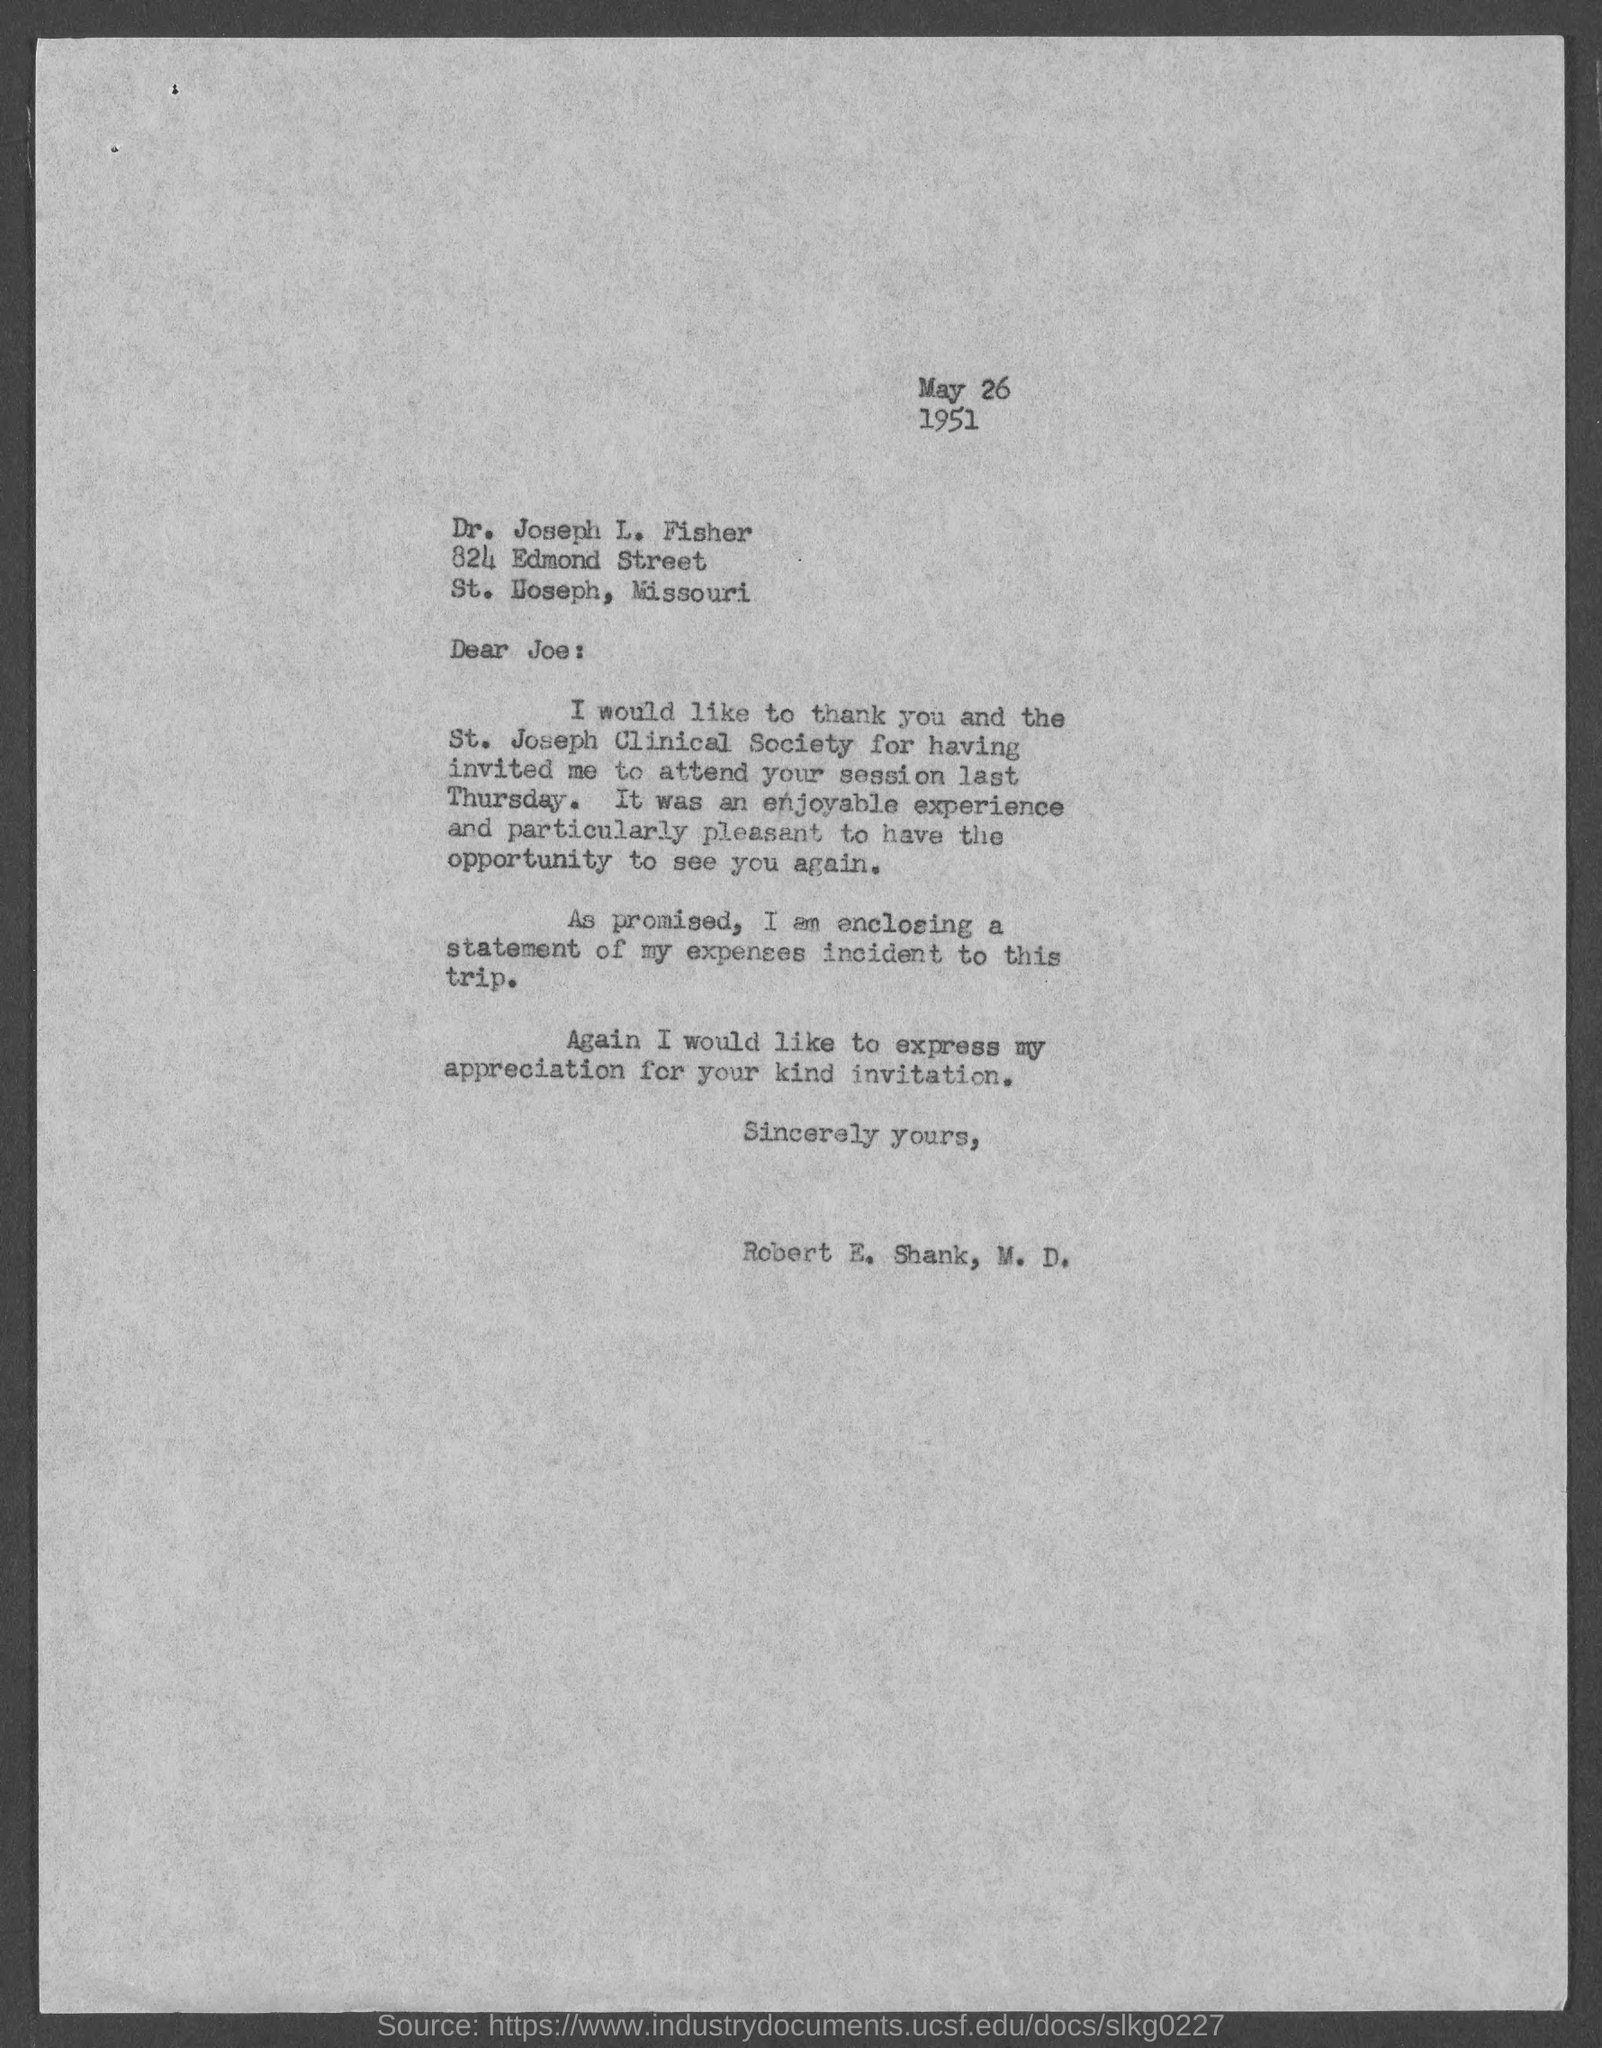Specify some key components in this picture. The date mentioned in this letter is May 26, 1951. 